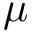<formula> <loc_0><loc_0><loc_500><loc_500>\mu</formula> 